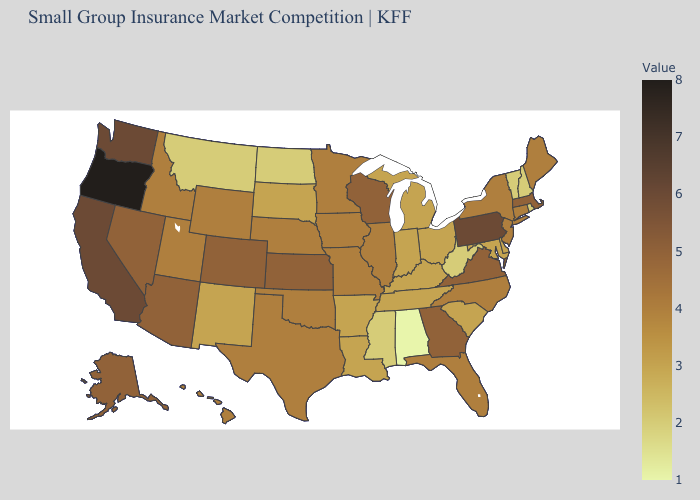Which states have the highest value in the USA?
Keep it brief. Oregon. Among the states that border Massachusetts , which have the highest value?
Quick response, please. Connecticut, New York. Does Oregon have the highest value in the USA?
Answer briefly. Yes. Is the legend a continuous bar?
Be succinct. Yes. 